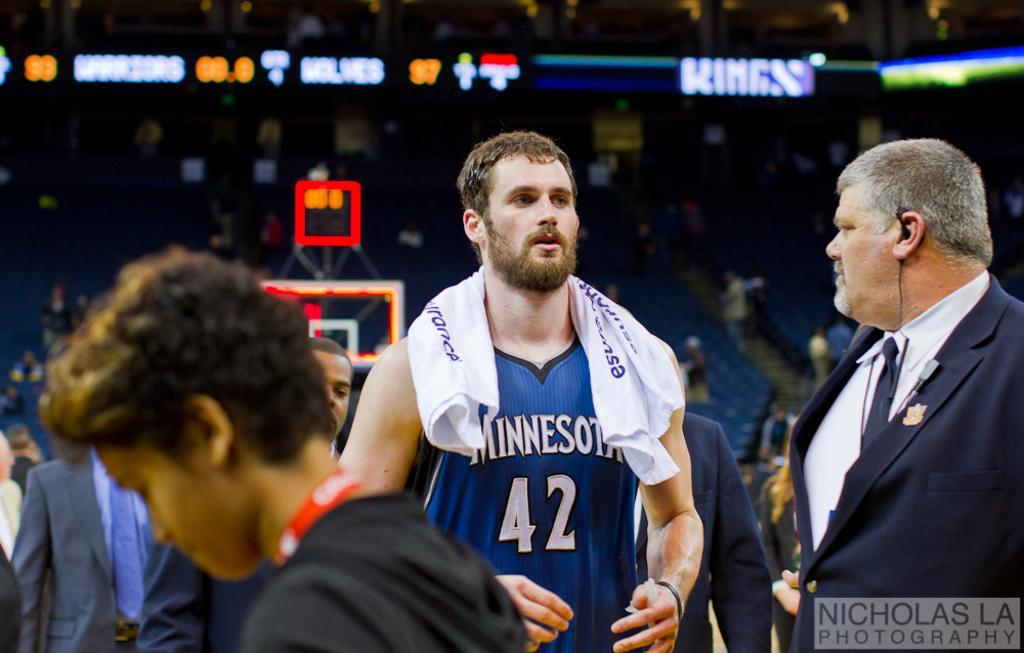How would you summarize this image in a sentence or two? This image is taken in a stadium. At the bottom of the image a few people are standing on the floor. On the right side of the image a man is standing on the floor. In the background a few people are sitting on the chairs and there are many empty chairs. There are a few boards with text on them. 